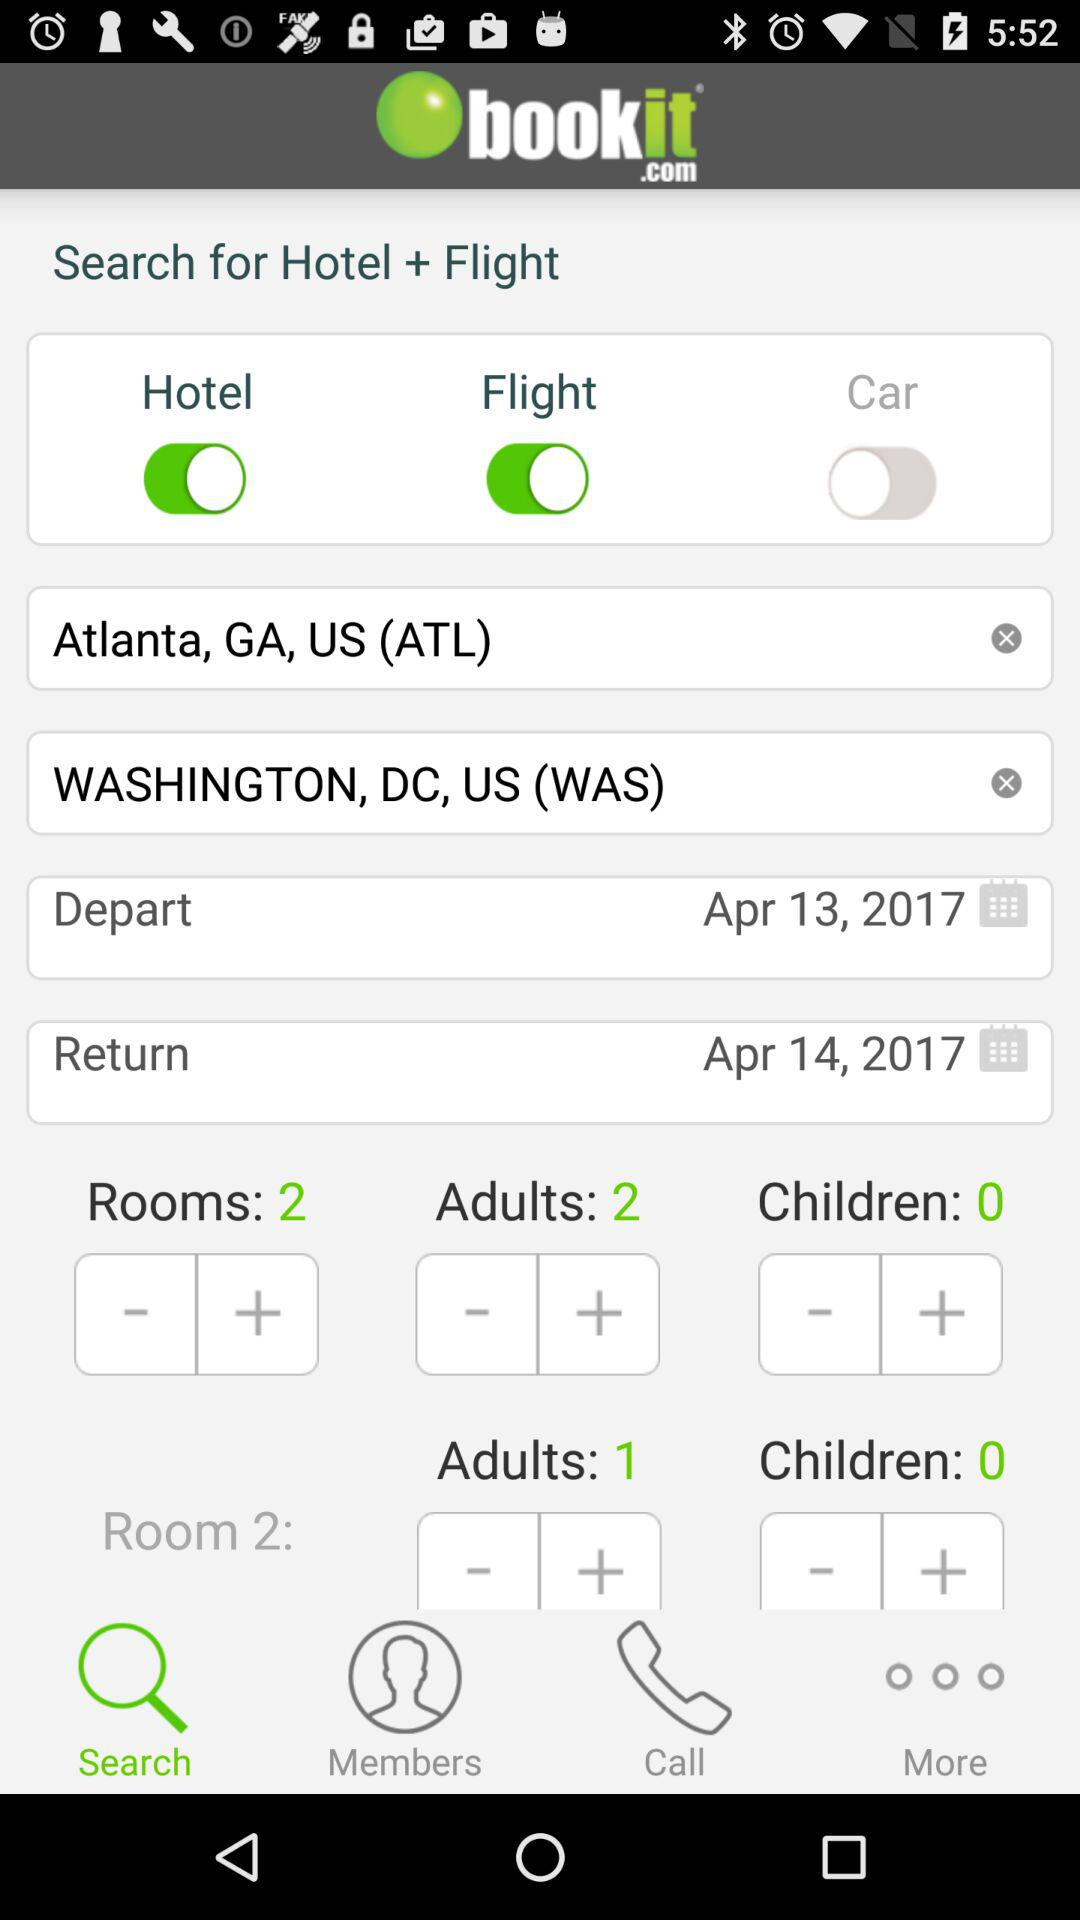How many days are there between the departure and return dates?
Answer the question using a single word or phrase. 1 